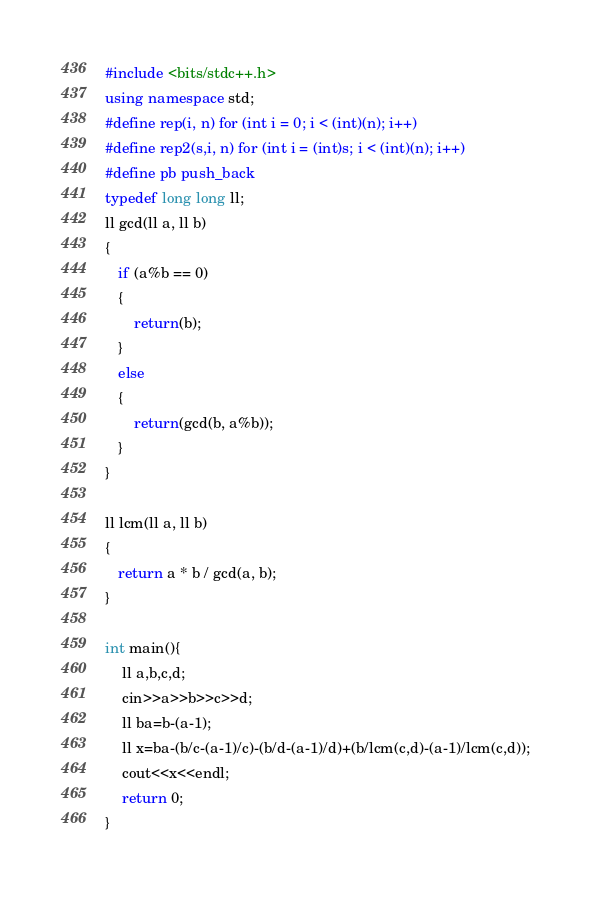Convert code to text. <code><loc_0><loc_0><loc_500><loc_500><_C++_>#include <bits/stdc++.h>
using namespace std;
#define rep(i, n) for (int i = 0; i < (int)(n); i++)
#define rep2(s,i, n) for (int i = (int)s; i < (int)(n); i++)
#define pb push_back
typedef long long ll;
ll gcd(ll a, ll b)
{
   if (a%b == 0)
   {
       return(b);
   }
   else
   {
       return(gcd(b, a%b));
   }
}

ll lcm(ll a, ll b)
{
   return a * b / gcd(a, b);
}
  
int main(){
    ll a,b,c,d;
    cin>>a>>b>>c>>d;
    ll ba=b-(a-1);
    ll x=ba-(b/c-(a-1)/c)-(b/d-(a-1)/d)+(b/lcm(c,d)-(a-1)/lcm(c,d));
    cout<<x<<endl;
    return 0;
}</code> 